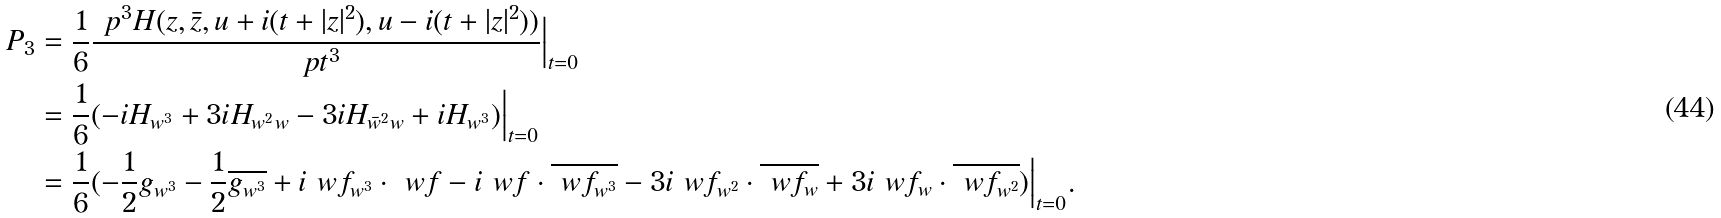Convert formula to latex. <formula><loc_0><loc_0><loc_500><loc_500>P _ { 3 } & = \frac { 1 } { 6 } \frac { \ p ^ { 3 } H ( z , \bar { z } , u + i ( t + | z | ^ { 2 } ) , u - i ( t + | z | ^ { 2 } ) ) } { \ p t ^ { 3 } } \Big | _ { t = 0 } \\ & = \frac { 1 } { 6 } ( - i H _ { w ^ { 3 } } + 3 i H _ { w ^ { 2 } w } - 3 i H _ { \bar { w } ^ { 2 } w } + i H _ { w ^ { 3 } } ) \Big | _ { t = 0 } \\ & = \frac { 1 } { 6 } ( - \frac { 1 } { 2 } g _ { w ^ { 3 } } - \frac { 1 } { 2 } \overline { g _ { w ^ { 3 } } } + i \ w f _ { w ^ { 3 } } \cdot { \ w f } - i \ w f \cdot \overline { \ w f _ { w ^ { 3 } } } - 3 i \ w f _ { w ^ { 2 } } \cdot \overline { \ w f _ { w } } + 3 i \ w f _ { w } \cdot \overline { \ w f _ { w ^ { 2 } } } ) \Big | _ { t = 0 } .</formula> 